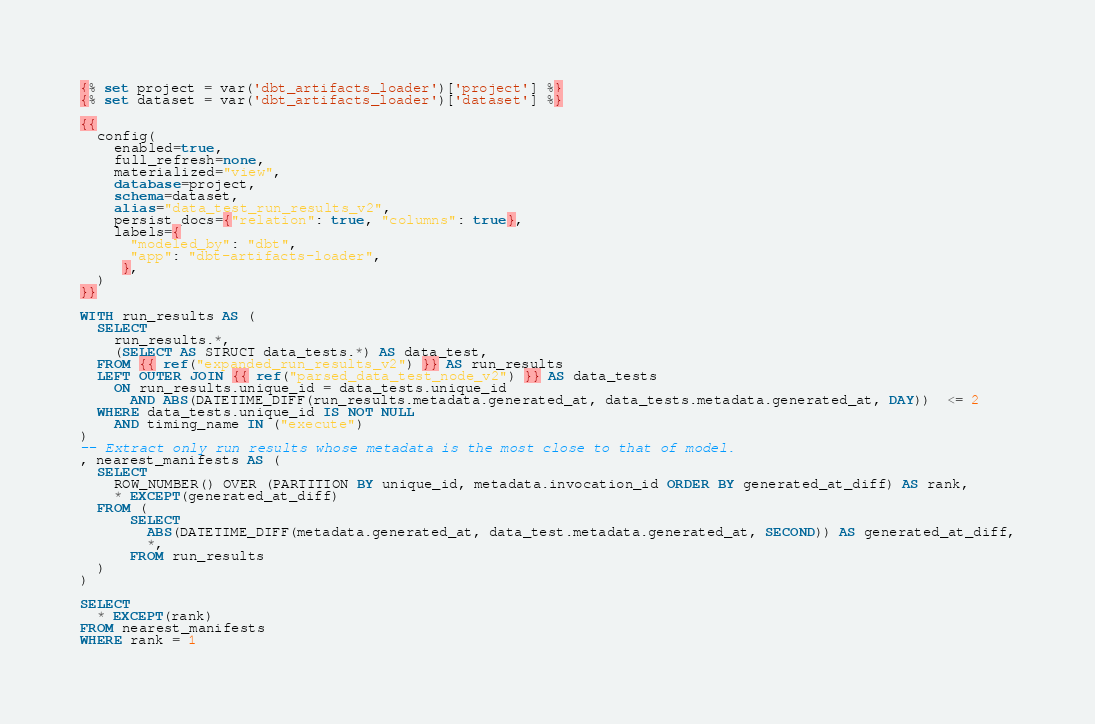Convert code to text. <code><loc_0><loc_0><loc_500><loc_500><_SQL_>{% set project = var('dbt_artifacts_loader')['project'] %}
{% set dataset = var('dbt_artifacts_loader')['dataset'] %}

{{
  config(
    enabled=true,
    full_refresh=none,
    materialized="view",
    database=project,
    schema=dataset,
    alias="data_test_run_results_v2",
    persist_docs={"relation": true, "columns": true},
    labels={
      "modeled_by": "dbt",
      "app": "dbt-artifacts-loader",
     },
  )
}}

WITH run_results AS (
  SELECT
    run_results.*,
    (SELECT AS STRUCT data_tests.*) AS data_test,
  FROM {{ ref("expanded_run_results_v2") }} AS run_results
  LEFT OUTER JOIN {{ ref("parsed_data_test_node_v2") }} AS data_tests
    ON run_results.unique_id = data_tests.unique_id
      AND ABS(DATETIME_DIFF(run_results.metadata.generated_at, data_tests.metadata.generated_at, DAY))  <= 2
  WHERE data_tests.unique_id IS NOT NULL
    AND timing_name IN ("execute")
)
-- Extract only run results whose metadata is the most close to that of model.
, nearest_manifests AS (
  SELECT
    ROW_NUMBER() OVER (PARTITION BY unique_id, metadata.invocation_id ORDER BY generated_at_diff) AS rank,
    * EXCEPT(generated_at_diff)
  FROM (
      SELECT
        ABS(DATETIME_DIFF(metadata.generated_at, data_test.metadata.generated_at, SECOND)) AS generated_at_diff,
        *,
      FROM run_results
  )
)

SELECT
  * EXCEPT(rank)
FROM nearest_manifests
WHERE rank = 1
</code> 